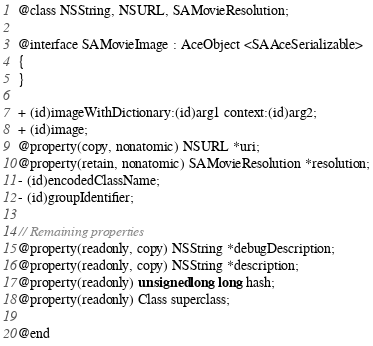<code> <loc_0><loc_0><loc_500><loc_500><_C_>@class NSString, NSURL, SAMovieResolution;

@interface SAMovieImage : AceObject <SAAceSerializable>
{
}

+ (id)imageWithDictionary:(id)arg1 context:(id)arg2;
+ (id)image;
@property(copy, nonatomic) NSURL *uri;
@property(retain, nonatomic) SAMovieResolution *resolution;
- (id)encodedClassName;
- (id)groupIdentifier;

// Remaining properties
@property(readonly, copy) NSString *debugDescription;
@property(readonly, copy) NSString *description;
@property(readonly) unsigned long long hash;
@property(readonly) Class superclass;

@end

</code> 